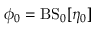<formula> <loc_0><loc_0><loc_500><loc_500>\phi _ { 0 } = B S _ { 0 } [ \eta _ { 0 } ]</formula> 